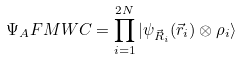Convert formula to latex. <formula><loc_0><loc_0><loc_500><loc_500>\Psi _ { A } F M W C = \prod ^ { 2 N } _ { i = 1 } | \psi _ { \vec { R } _ { i } } ( \vec { r } _ { i } ) \otimes \rho _ { i } \rangle</formula> 